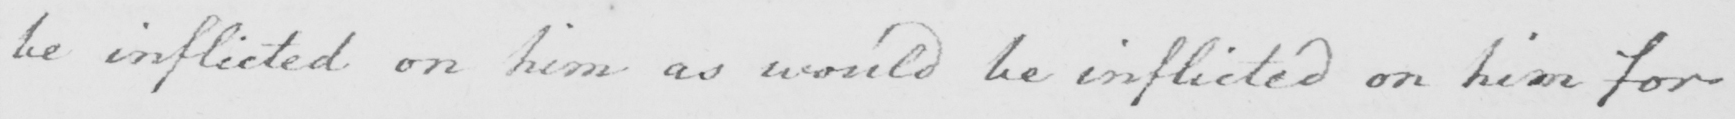Transcribe the text shown in this historical manuscript line. be inflicted on him as would be inflicted on him for 